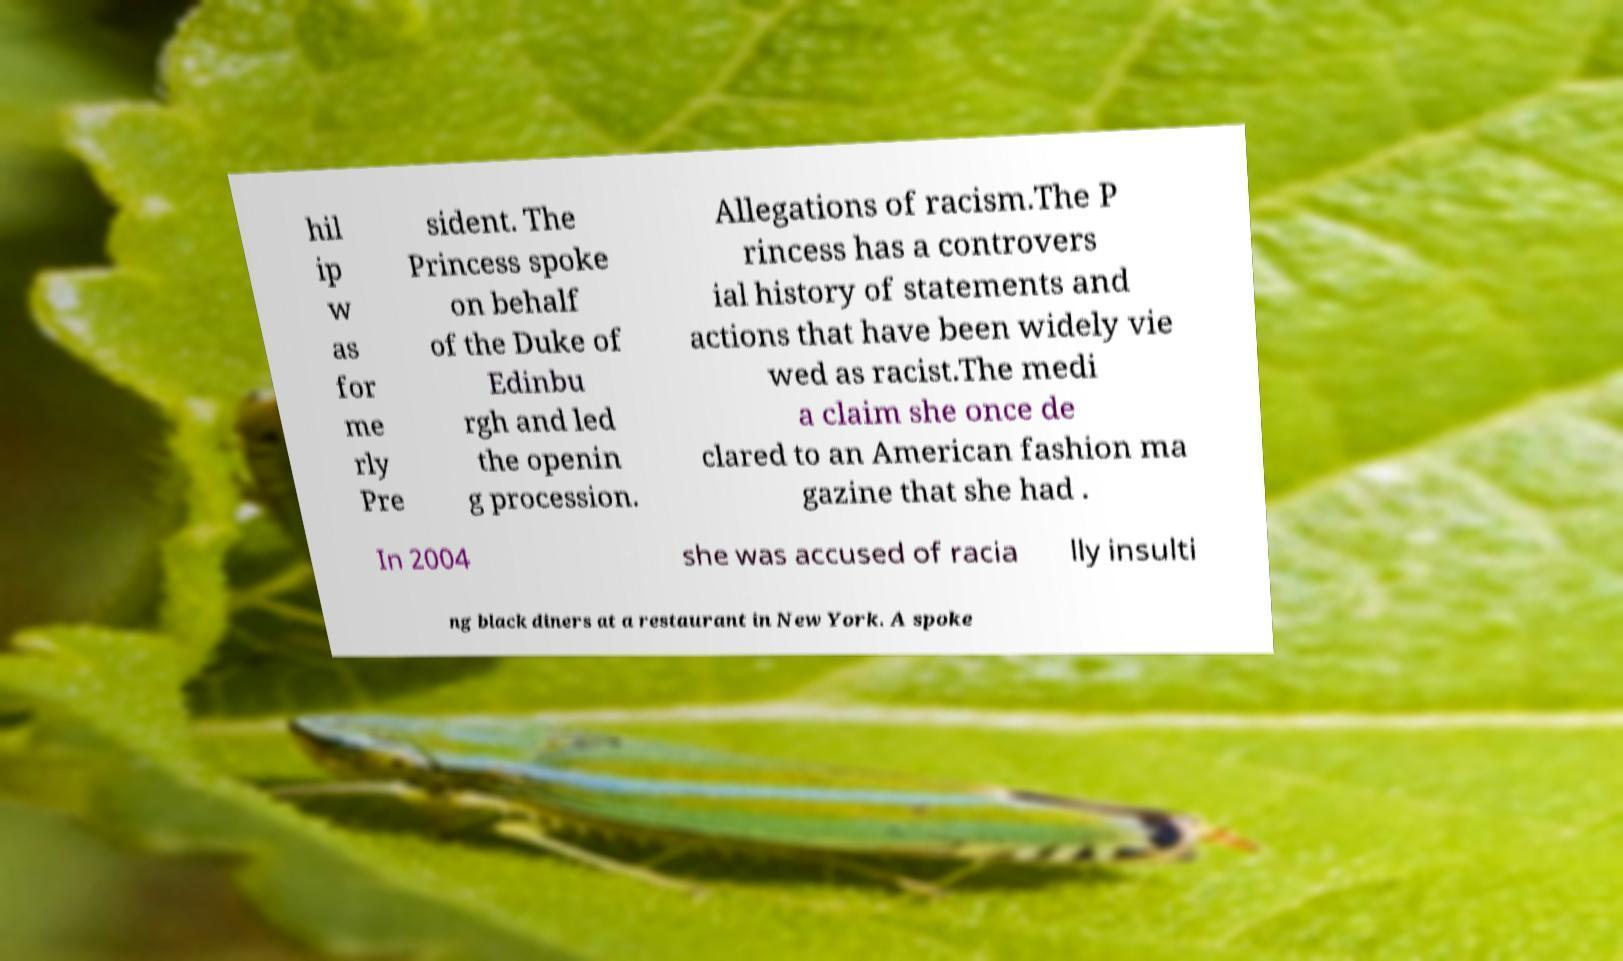Could you assist in decoding the text presented in this image and type it out clearly? hil ip w as for me rly Pre sident. The Princess spoke on behalf of the Duke of Edinbu rgh and led the openin g procession. Allegations of racism.The P rincess has a controvers ial history of statements and actions that have been widely vie wed as racist.The medi a claim she once de clared to an American fashion ma gazine that she had . In 2004 she was accused of racia lly insulti ng black diners at a restaurant in New York. A spoke 